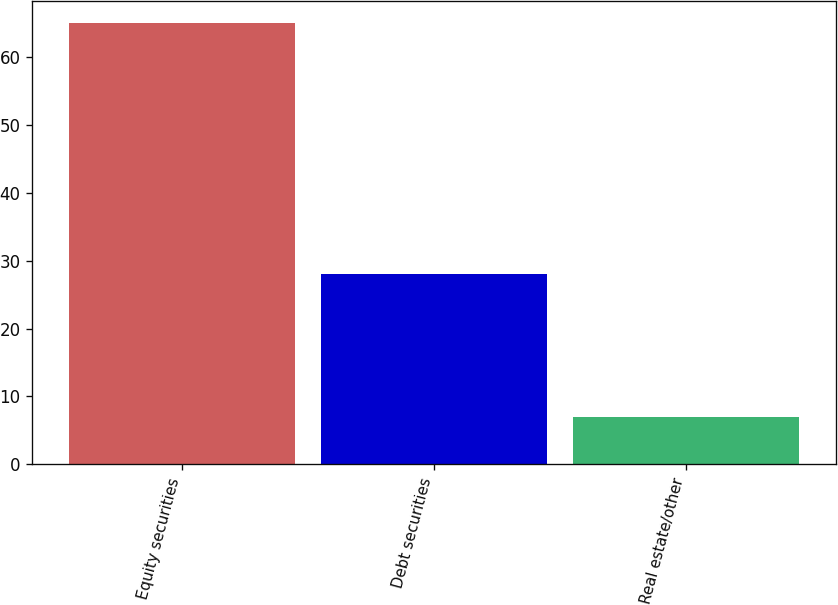Convert chart to OTSL. <chart><loc_0><loc_0><loc_500><loc_500><bar_chart><fcel>Equity securities<fcel>Debt securities<fcel>Real estate/other<nl><fcel>65<fcel>28<fcel>7<nl></chart> 